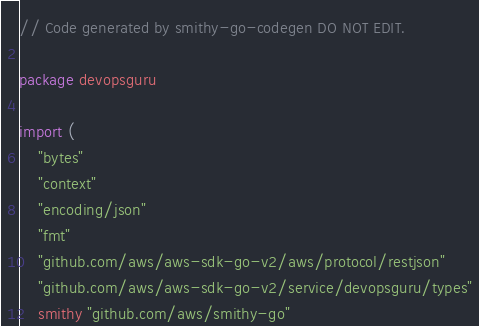Convert code to text. <code><loc_0><loc_0><loc_500><loc_500><_Go_>// Code generated by smithy-go-codegen DO NOT EDIT.

package devopsguru

import (
	"bytes"
	"context"
	"encoding/json"
	"fmt"
	"github.com/aws/aws-sdk-go-v2/aws/protocol/restjson"
	"github.com/aws/aws-sdk-go-v2/service/devopsguru/types"
	smithy "github.com/aws/smithy-go"</code> 